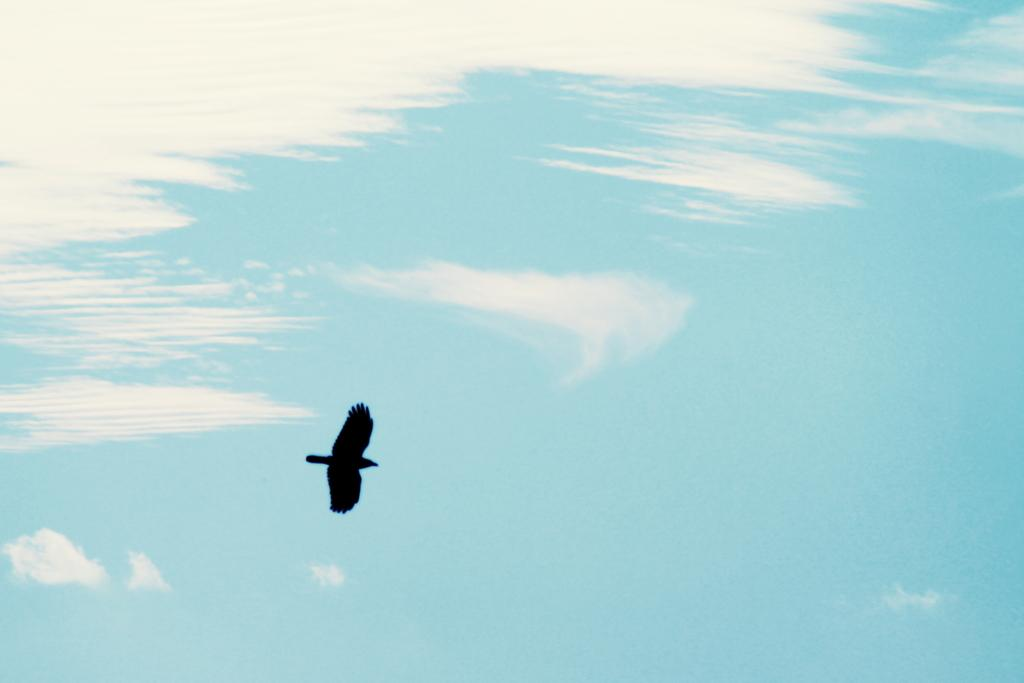What type of animal can be seen in the image? There is a bird in the image. What is the color of the sky in the background? The sky in the background is blue and white in color. How many babies are crawling out of the drawer in the image? There are no babies or drawers present in the image; it features a bird and a blue and white sky. 